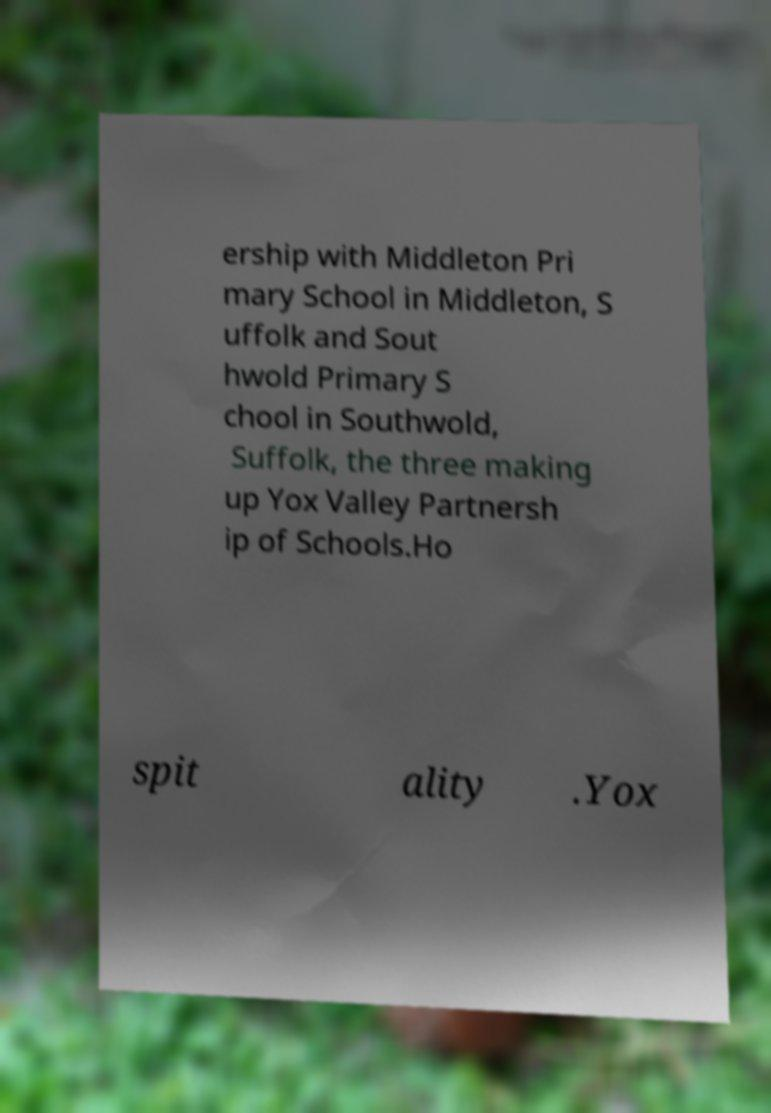Can you accurately transcribe the text from the provided image for me? ership with Middleton Pri mary School in Middleton, S uffolk and Sout hwold Primary S chool in Southwold, Suffolk, the three making up Yox Valley Partnersh ip of Schools.Ho spit ality .Yox 